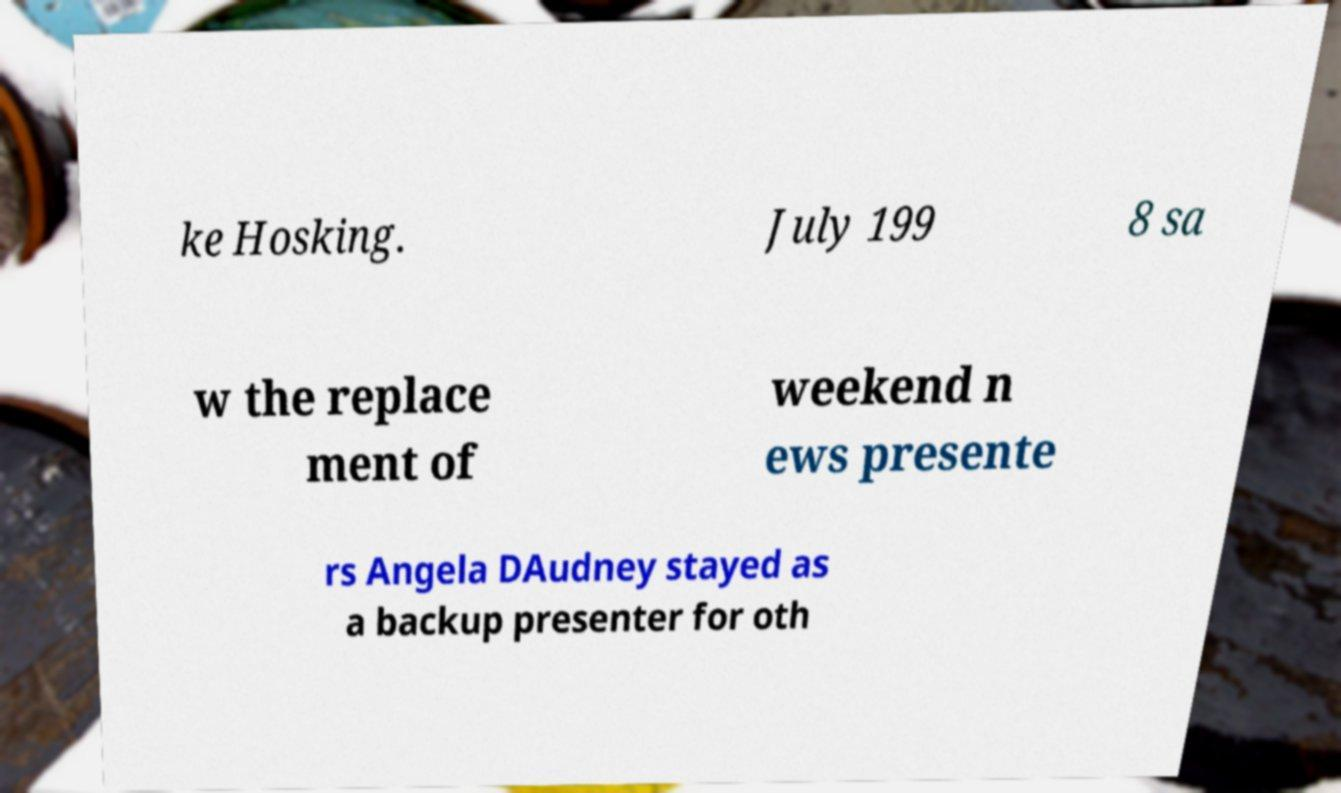What messages or text are displayed in this image? I need them in a readable, typed format. ke Hosking. July 199 8 sa w the replace ment of weekend n ews presente rs Angela DAudney stayed as a backup presenter for oth 